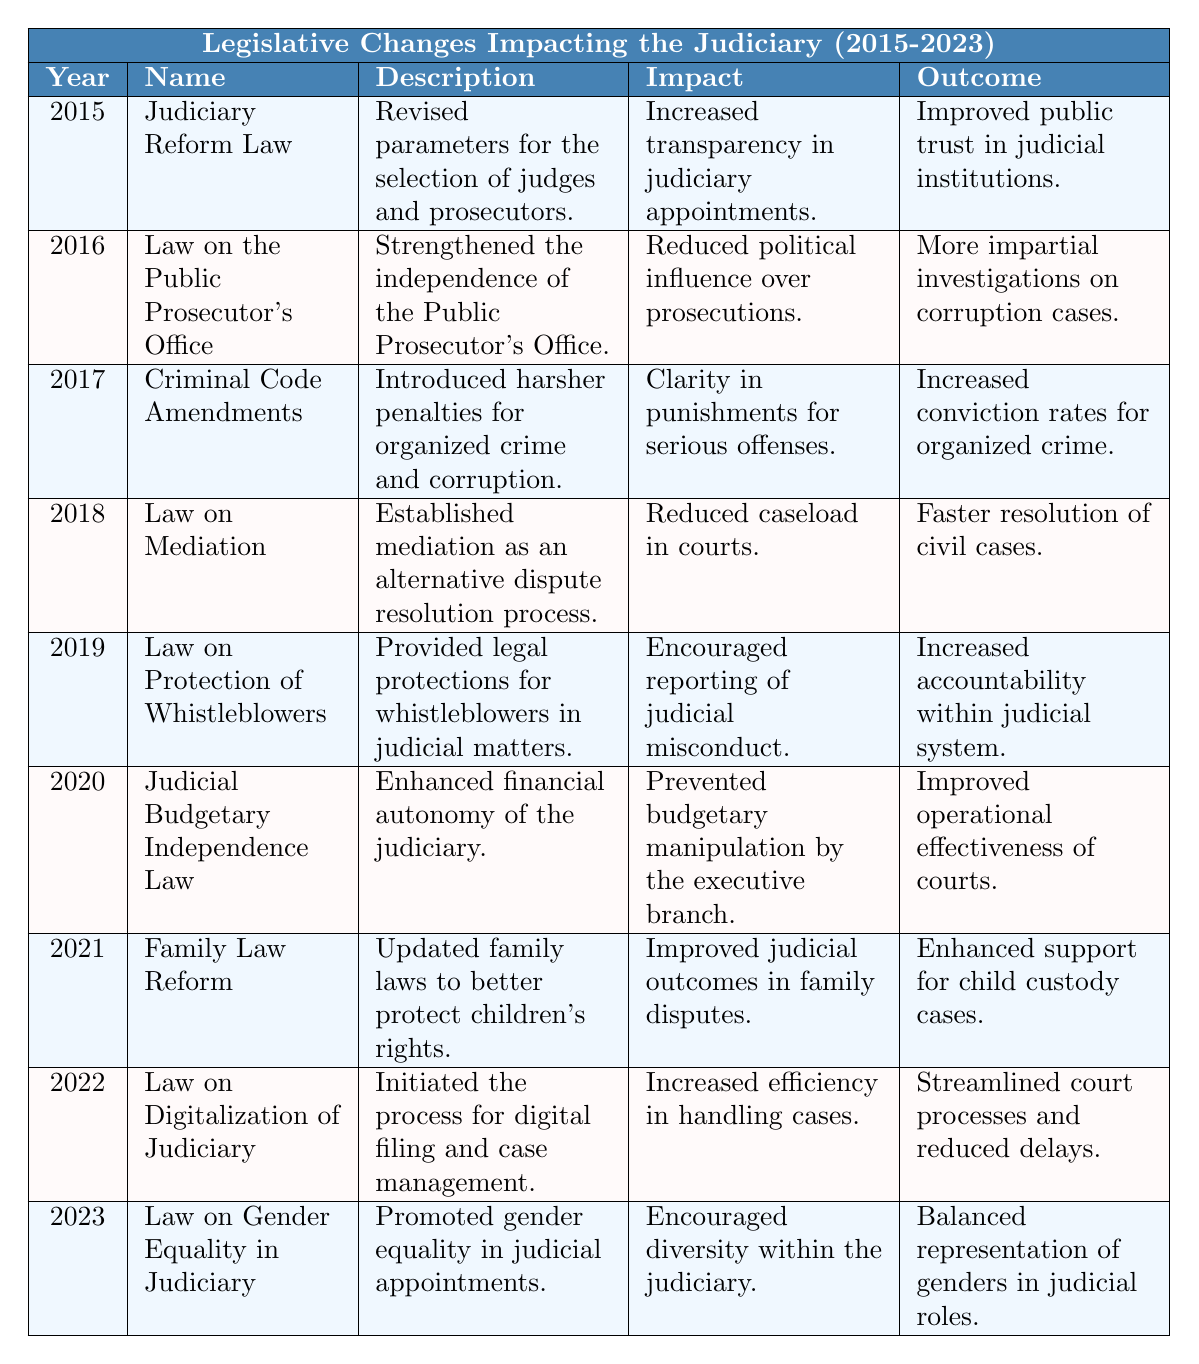What legislative change occurred in 2015? The table indicates that the Judiciary Reform Law was enacted in 2015. This law revised the parameters for the selection of judges and prosecutors.
Answer: Judiciary Reform Law What was the main impact of the Law on the Public Prosecutor's Office in 2016? According to the table, the main impact of the Law on the Public Prosecutor's Office was the reduction of political influence over prosecutions.
Answer: Reduced political influence What outcome did the Criminal Code Amendments of 2017 achieve? The outcome of the Criminal Code Amendments in 2017 was an increased conviction rate for organized crime, as noted in the table.
Answer: Increased conviction rates How many legislative changes focused on enhancing judicial independence from 2015 to 2023? The table shows three legislative changes aimed at enhancing judicial independence: the Judiciary Reform Law (2015), the Law on the Public Prosecutor's Office (2016), and the Judicial Budgetary Independence Law (2020). Therefore, the total is 3.
Answer: 3 Did the Law on Mediation in 2018 improve the speed of case resolutions? Yes, the table specifies that the Law on Mediation established an alternative dispute resolution process, resulting in faster resolution of civil cases.
Answer: Yes What was the effect of the Law on Digitalization of Judiciary enacted in 2022? The table states that the Law on Digitalization of Judiciary increased efficiency in handling cases, leading to streamlined court processes and reduced delays.
Answer: Increased efficiency Which year's legislative change focused on children's rights, and what was the outcome? The Family Law Reform enacted in 2021 updated family laws to better protect children's rights, with the outcome being enhanced support for child custody cases, as per the table.
Answer: 2021; enhanced support for child custody cases What impact did the Law on Protection of Whistleblowers have on the judicial system in 2019? The table indicates that the Law on Protection of Whistleblowers encouraged reporting of judicial misconduct, leading to increased accountability within the judicial system.
Answer: Increased accountability In what year was gender equality in judicial appointments promoted? The Law on Gender Equality in Judiciary was introduced in 2023, according to the table.
Answer: 2023 Summarizing all legislative changes from 2015 to 2023, how many laws aimed specifically at improving transparency and accountability? From the table, the laws aimed at improving transparency and accountability include the Judiciary Reform Law (2015), Law on the Public Prosecutor's Office (2016), and Law on Protection of Whistleblowers (2019). Thus, there are three such laws.
Answer: 3 